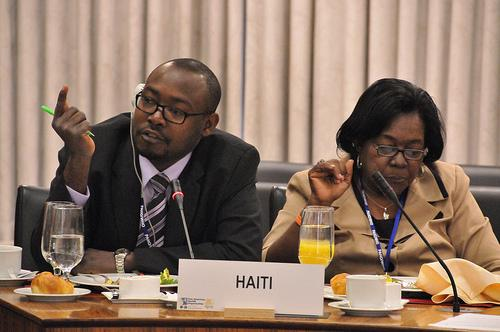Question: what color is the woman's jacket?
Choices:
A. Tan.
B. Teal.
C. Purple.
D. Neon.
Answer with the letter. Answer: A Question: what country is on the sign?
Choices:
A. Switzerland.
B. England.
C. United States.
D. Haiti.
Answer with the letter. Answer: D Question: what color is the napkin?
Choices:
A. Teal.
B. Tan.
C. Purple.
D. Neon.
Answer with the letter. Answer: B Question: what pattern is the man's tie?
Choices:
A. Plaid.
B. Solid.
C. Polka dots.
D. Diagonal stripes.
Answer with the letter. Answer: D Question: what color is the man's suit?
Choices:
A. Teal.
B. Purple.
C. Neon.
D. Black.
Answer with the letter. Answer: D Question: what are they both wearing?
Choices:
A. Glasses.
B. Necklaces.
C. Lotion.
D. Shirts.
Answer with the letter. Answer: A 